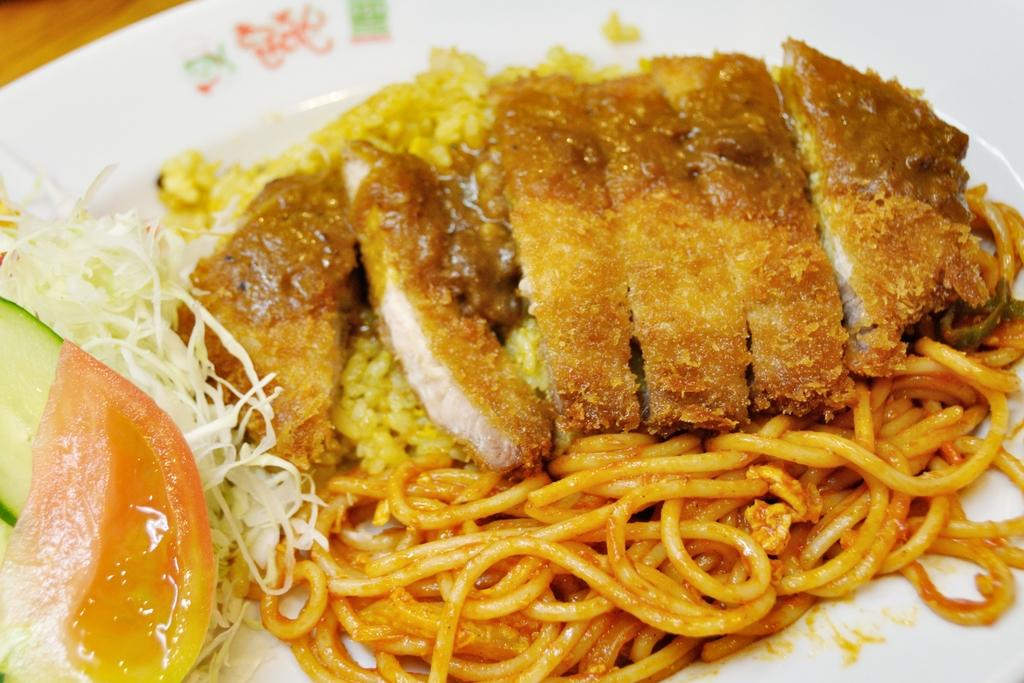What is in the center of the image? There is a plate in the center of the image. What type of food is on the plate? The plate contains chowmein and salad. What type of flower is growing on the wrist of the person in the image? There is no person or flower present in the image; it only features a plate with chowmein and salad. 